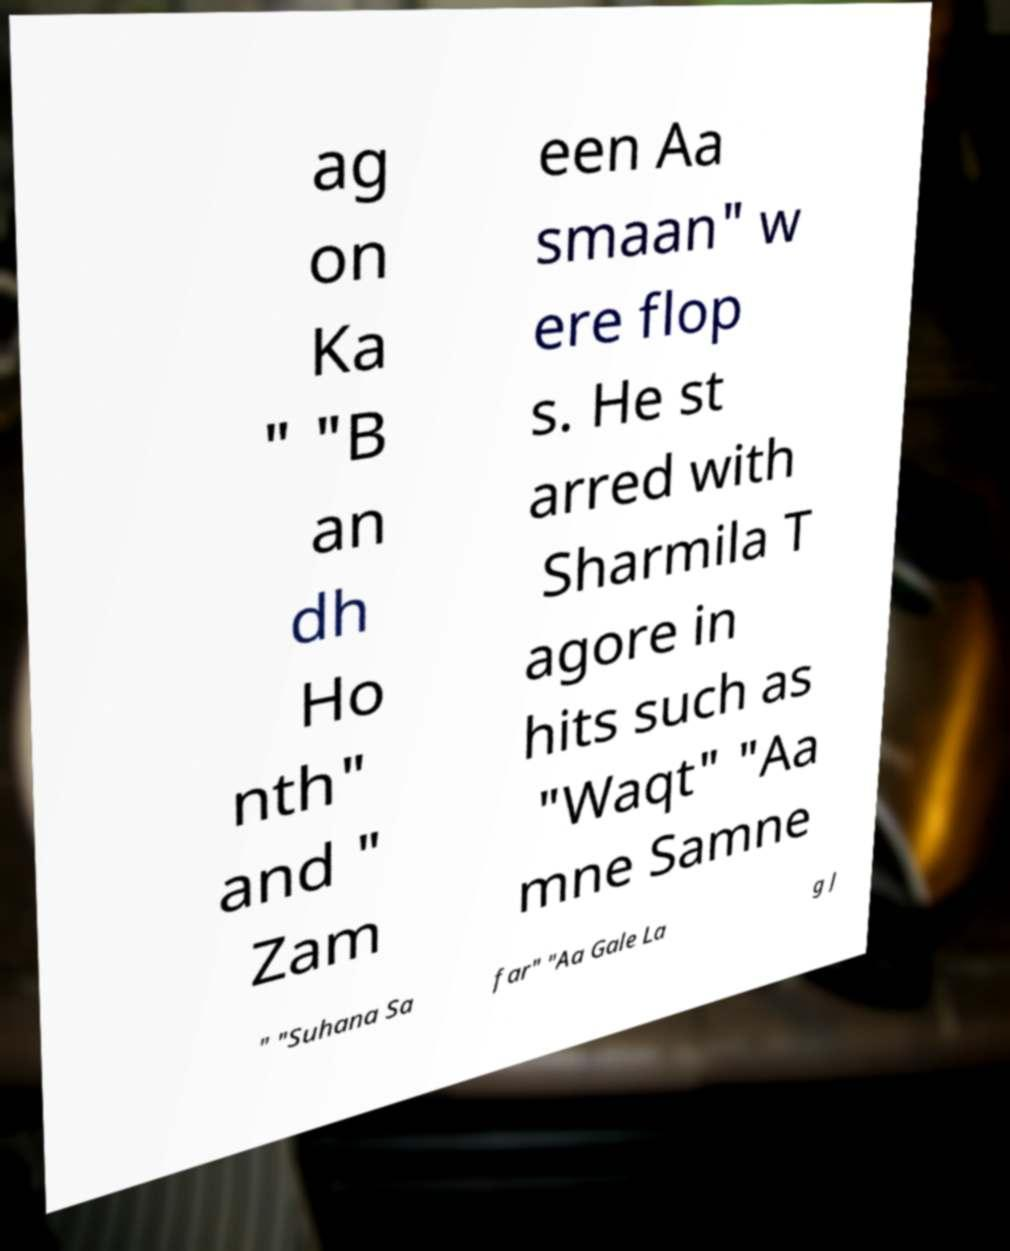Could you extract and type out the text from this image? ag on Ka " "B an dh Ho nth" and " Zam een Aa smaan" w ere flop s. He st arred with Sharmila T agore in hits such as "Waqt" "Aa mne Samne " "Suhana Sa far" "Aa Gale La g J 